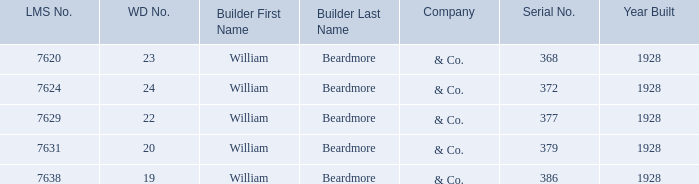Name the builder for wd number being 22 William Beardmore & Co. 